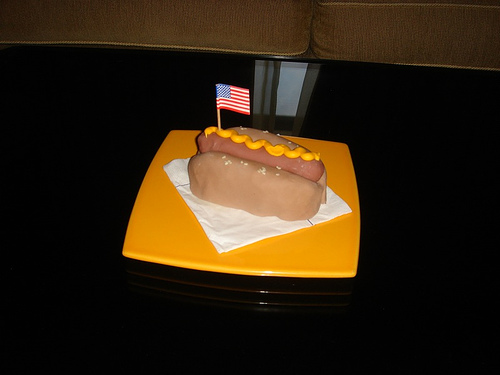What toppings are on this hotdog? The hotdog is topped with a generous swirl of mustard. 